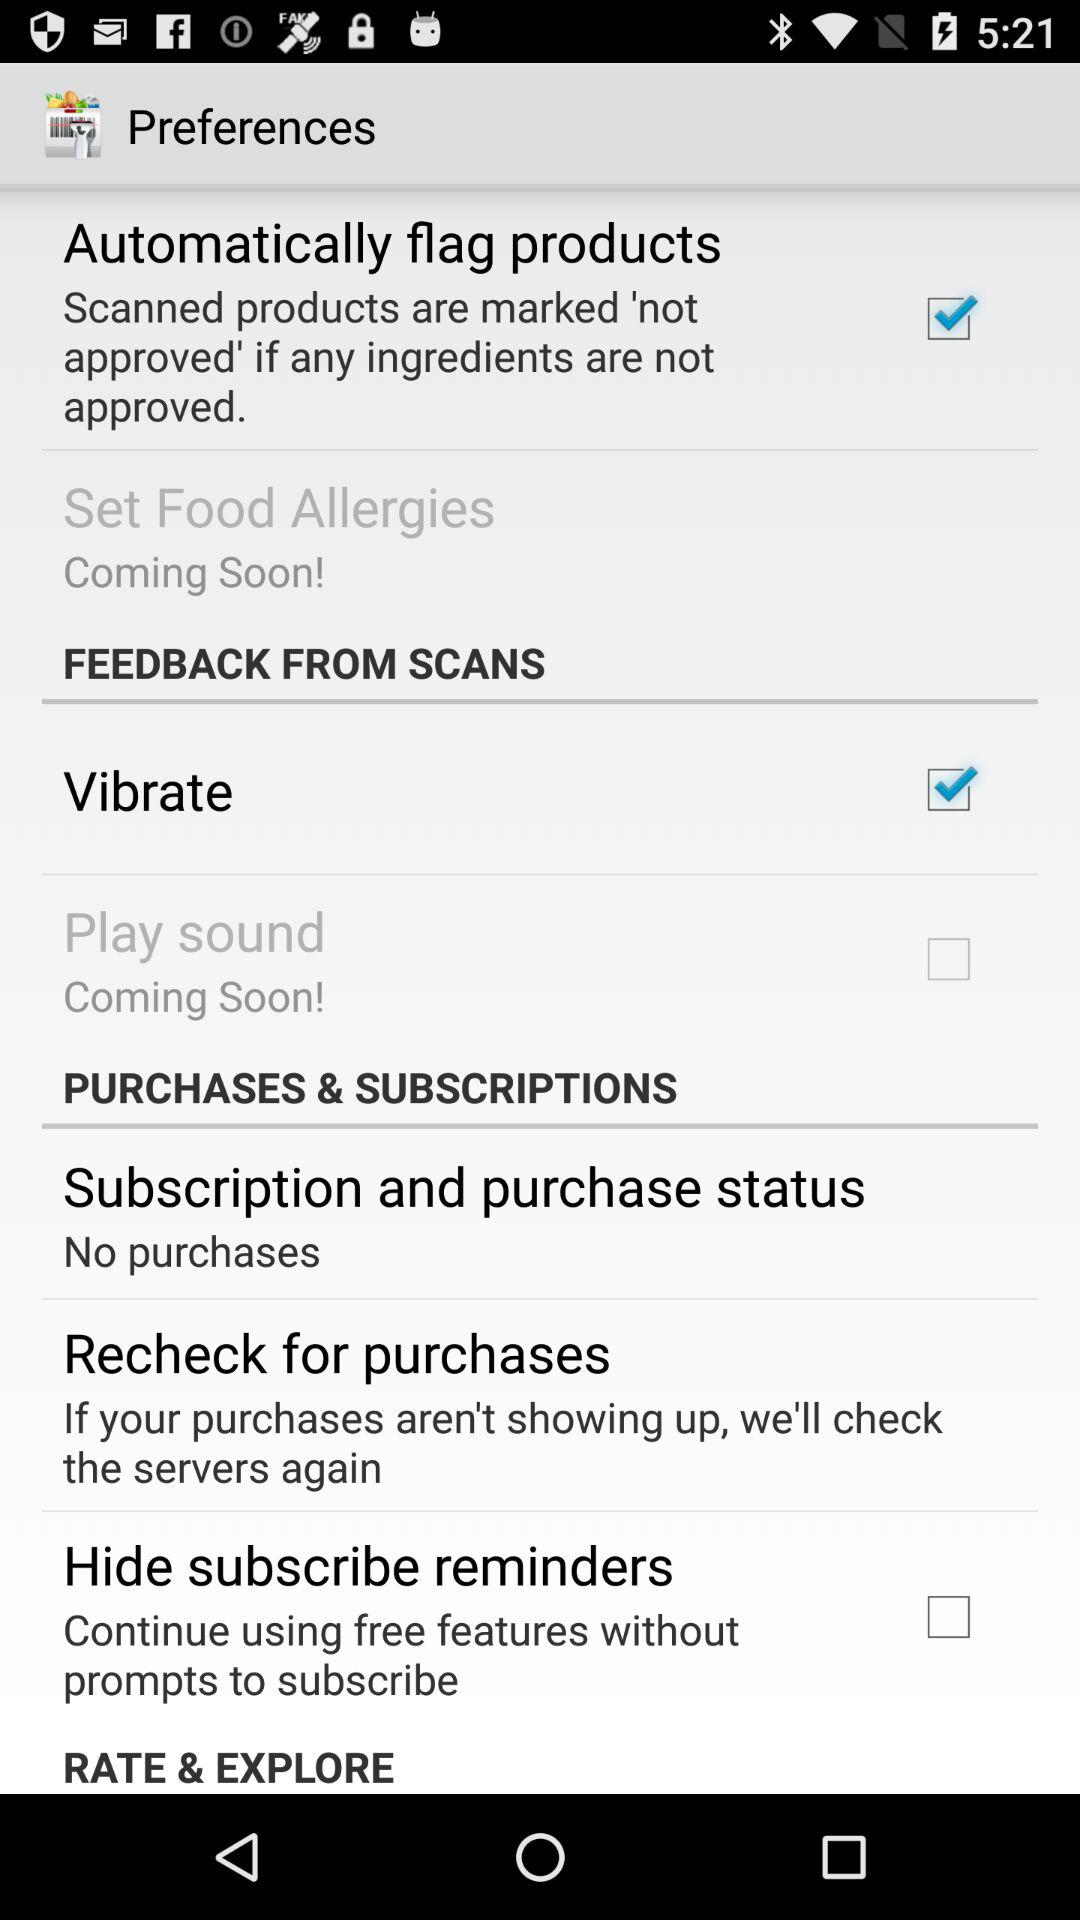What is the status of "Play sound"? The status is "off". 